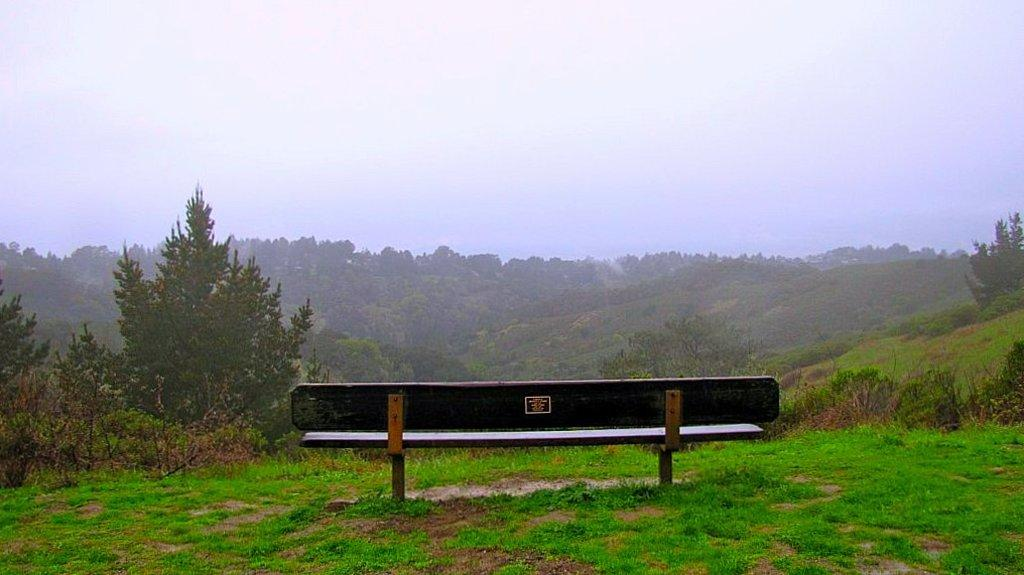What type of seating is present in the image? There is a bench in the image. What is on the ground beneath the bench? There is grass on the ground in the image. What can be seen in the distance behind the bench? There are trees in the background of the image. What is visible above the trees in the image? The sky is visible in the background of the image. How many copies of the peace symbol can be seen on the bench in the image? There is no peace symbol present on the bench or in the image. 